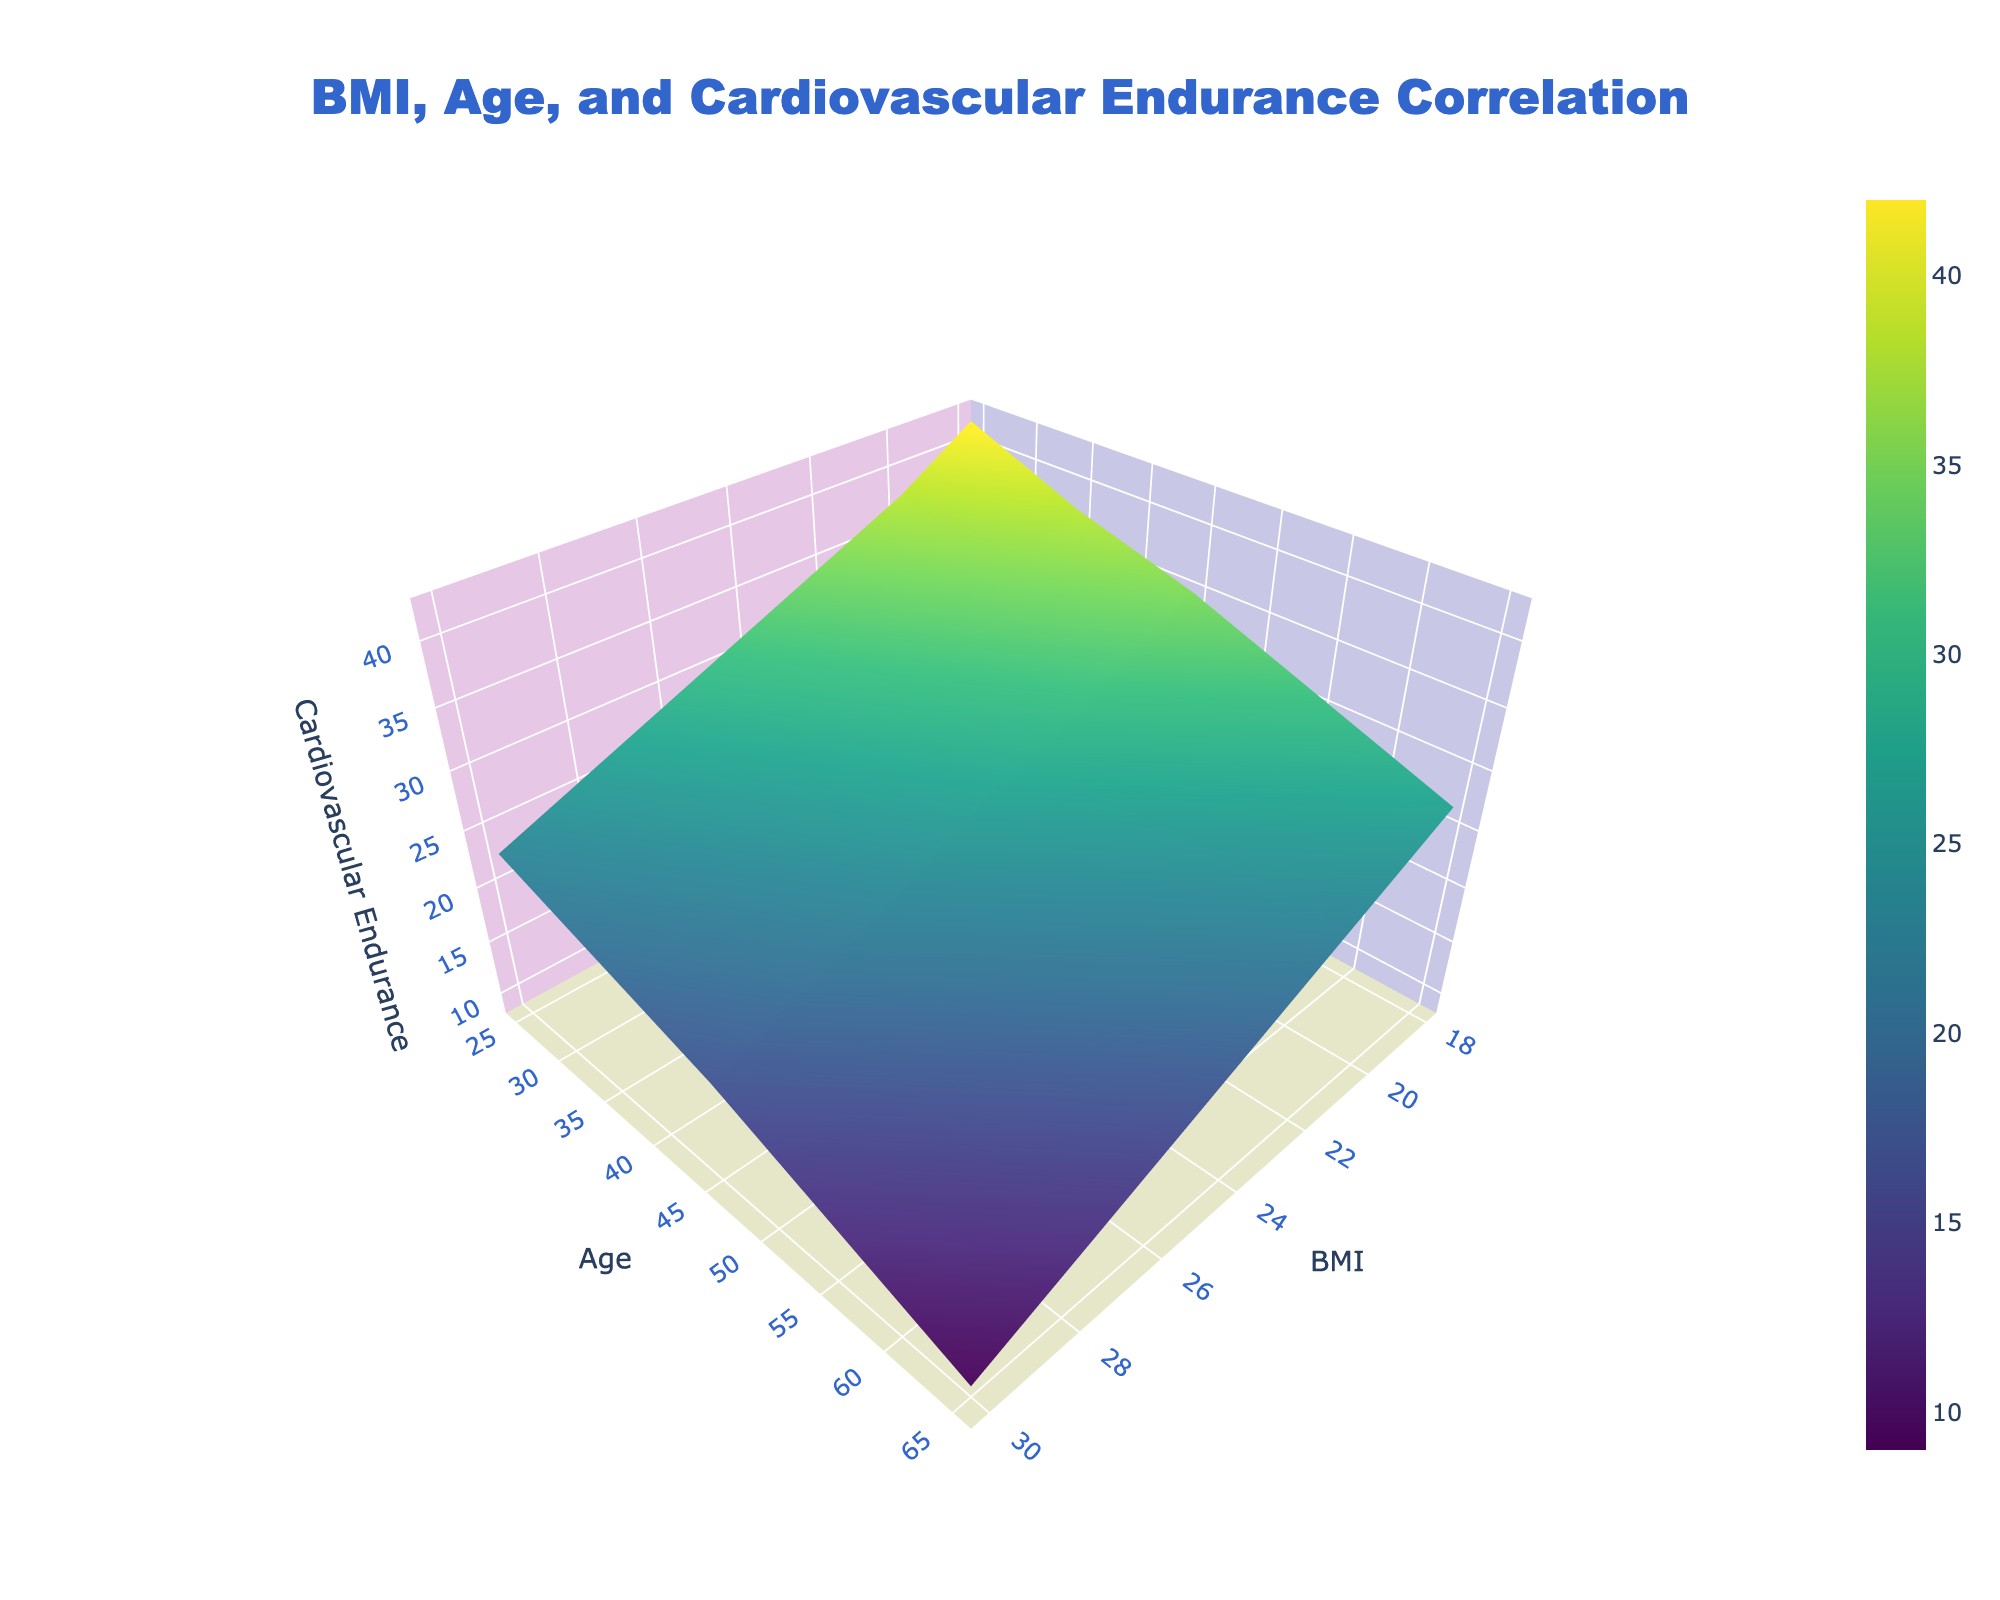What is the title of the plot? The plot title is typically displayed at the top center of the figure. In this case, it reads "BMI, Age, and Cardiovascular Endurance Correlation".
Answer: BMI, Age, and Cardiovascular Endurance Correlation What age range is covered in the plot? The information on the y-axis represents age, and by examining the plot, we can see that the age values range from 25 to 65.
Answer: 25 to 65 What is the color scheme used in the plot? By looking at the plot, we can see the colors range from shades of green to yellow, as indicated by the legend on the plot. This color scheme is called 'Viridis'.
Answer: Viridis Which BMI value shows the highest cardiovascular endurance for the age group of 55? To find this, locate the age group of 55 on the y-axis and look for the highest point along the cardiovascular endurance scale (z-axis) within this age group. The point with the highest cardiovascular endurance corresponds to a BMI of 18.
Answer: 18 For a 35-year-old individual, how does cardiovascular endurance change as BMI increases? Observing the age group of 35 on the plot, we see that cardiovascular endurance decreases as BMI increases.
Answer: Decreases Which age group generally has the highest cardiovascular endurance? Inspecting the plot, the 25-year-old age group consistently shows higher cardiovascular endurance compared to older age groups.
Answer: 25-year-old Compare the cardiovascular endurance of a 45-year-old with a BMI of 30 to that of a 25-year-old with the same BMI. Locate both age groups (45 and 25) and the BMI value of 30. The cardiovascular endurance for the 45-year-old (BMI 30) is significantly lower than that of the 25-year-old with the same BMI, with values at 17 and 23 respectively.
Answer: 45-year-old: 17, 25-year-old: 23 What is the general trend of cardiovascular endurance with respect to age for a person with a BMI of 22? By keeping BMI constant at 22 and moving along the age axis, we see a downward trend, meaning cardiovascular endurance tends to decrease as age increases.
Answer: Decreases What's the average cardiovascular endurance for people aged 45 with various BMI values? Sum the cardiovascular endurance values for age 45 across different BMI values: 35 + 32 + 29 + 26 + 23 + 20 + 17 = 182. Then, divide by the number of BMI values: 182/7 ≈ 26.
Answer: 26 How does cardiovascular endurance for individuals with a BMI of 26 change from age 35 to 65? Observe the cardiovascular endurance values at BMI 26 for ages 35, 45, 55, and 65. The values are 26, 23, 19, and 15 respectively, showing a decreasing trend.
Answer: Decreases 